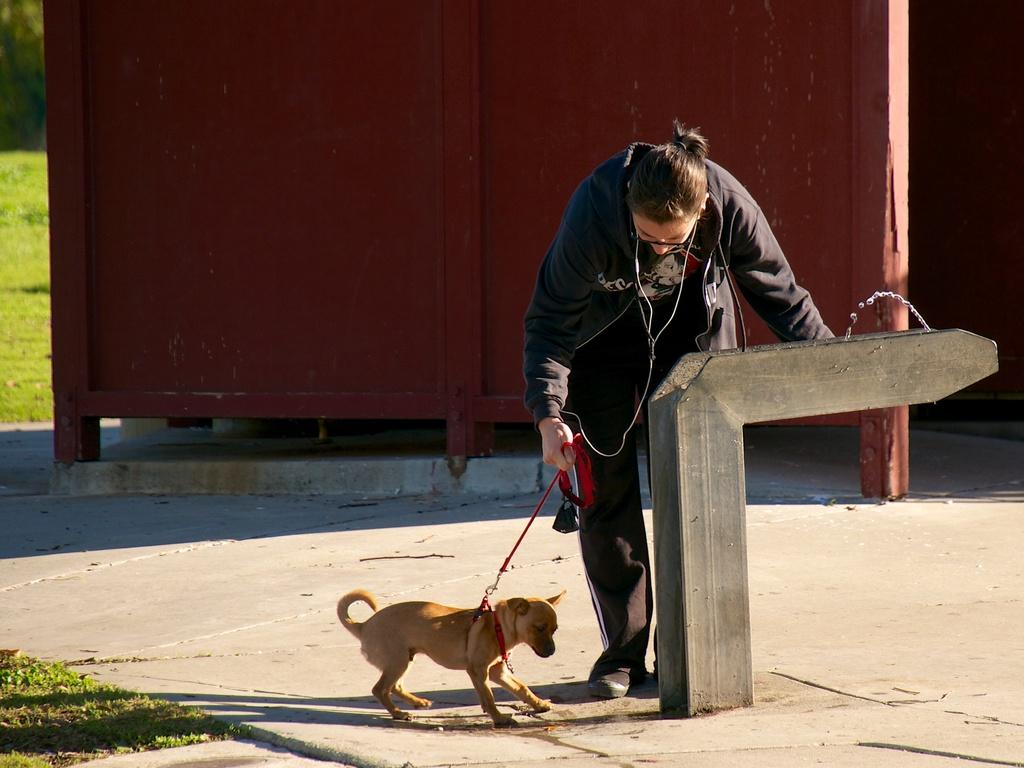Who is present in the image? There is a woman in the image. What is the woman holding? The woman is holding a belt. What other living creature is in the image? There is a dog in the image. What type of terrain is visible in the image? There is grass visible in the image. What is the background of the image composed of? The background of the image includes grass. What type of pleasure can be seen on the dog's face in the image? There is no indication of pleasure on the dog's face in the image, as facial expressions are not visible. 